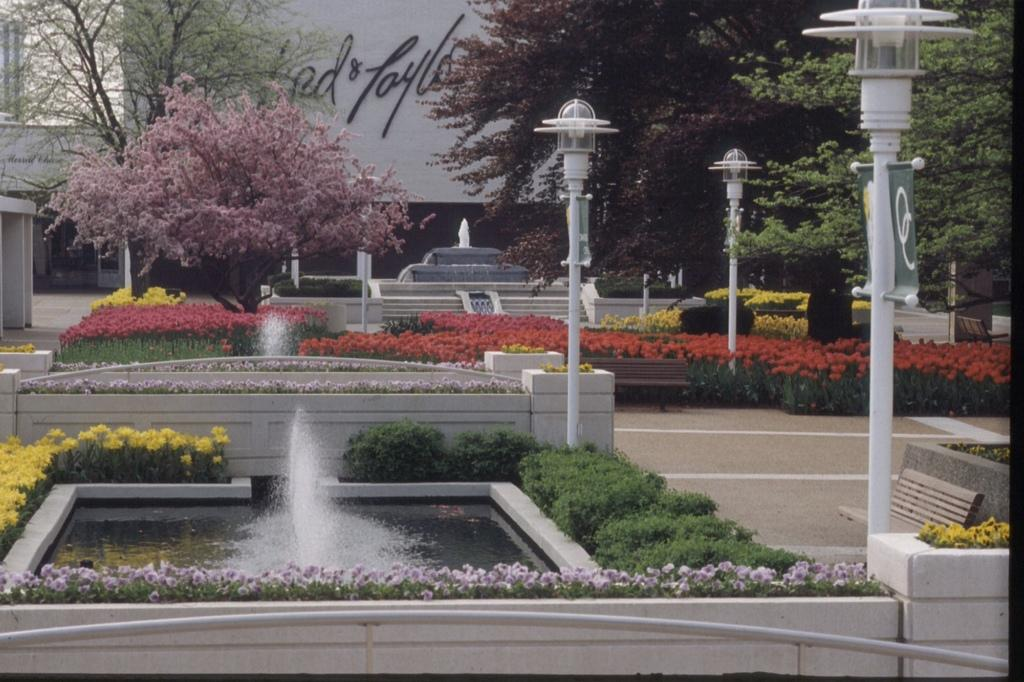What type of structures can be seen in the image? There are fountains, trees, light poles, buildings, and benches in the image. What colors are the flowers in the image? There are yellow, red, and pink flowers in the image. Where is the cellar located in the image? There is no cellar present in the image. What is the value of the fountains in the image? The value of the fountains cannot be determined from the image alone. 